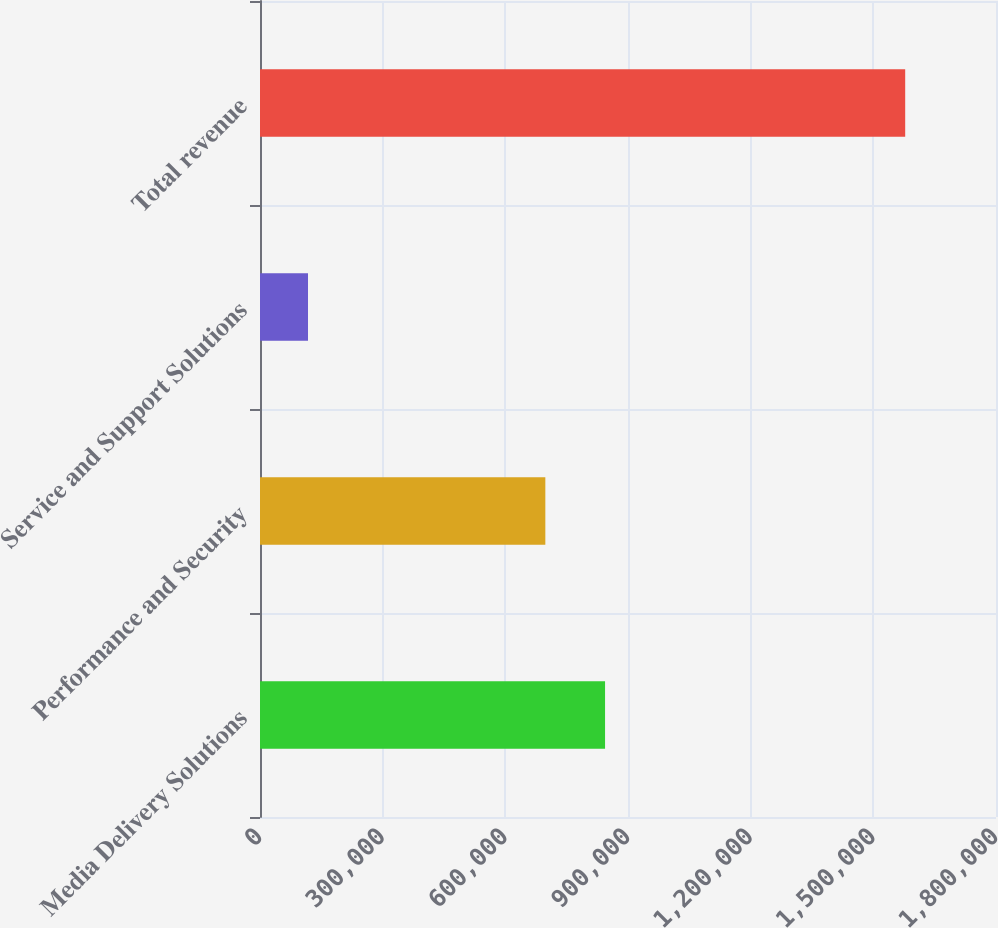<chart> <loc_0><loc_0><loc_500><loc_500><bar_chart><fcel>Media Delivery Solutions<fcel>Performance and Security<fcel>Service and Support Solutions<fcel>Total revenue<nl><fcel>843875<fcel>697825<fcel>117418<fcel>1.57792e+06<nl></chart> 